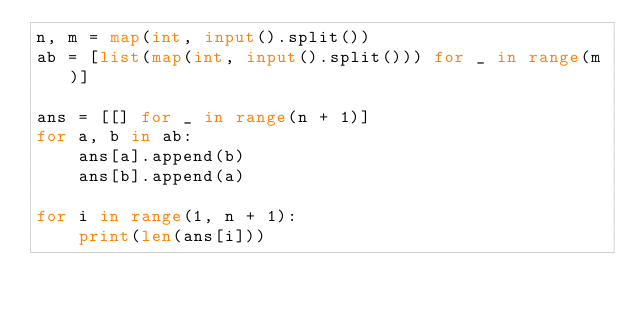Convert code to text. <code><loc_0><loc_0><loc_500><loc_500><_Python_>n, m = map(int, input().split())
ab = [list(map(int, input().split())) for _ in range(m)]

ans = [[] for _ in range(n + 1)]
for a, b in ab:
    ans[a].append(b)
    ans[b].append(a)

for i in range(1, n + 1):
    print(len(ans[i]))
</code> 